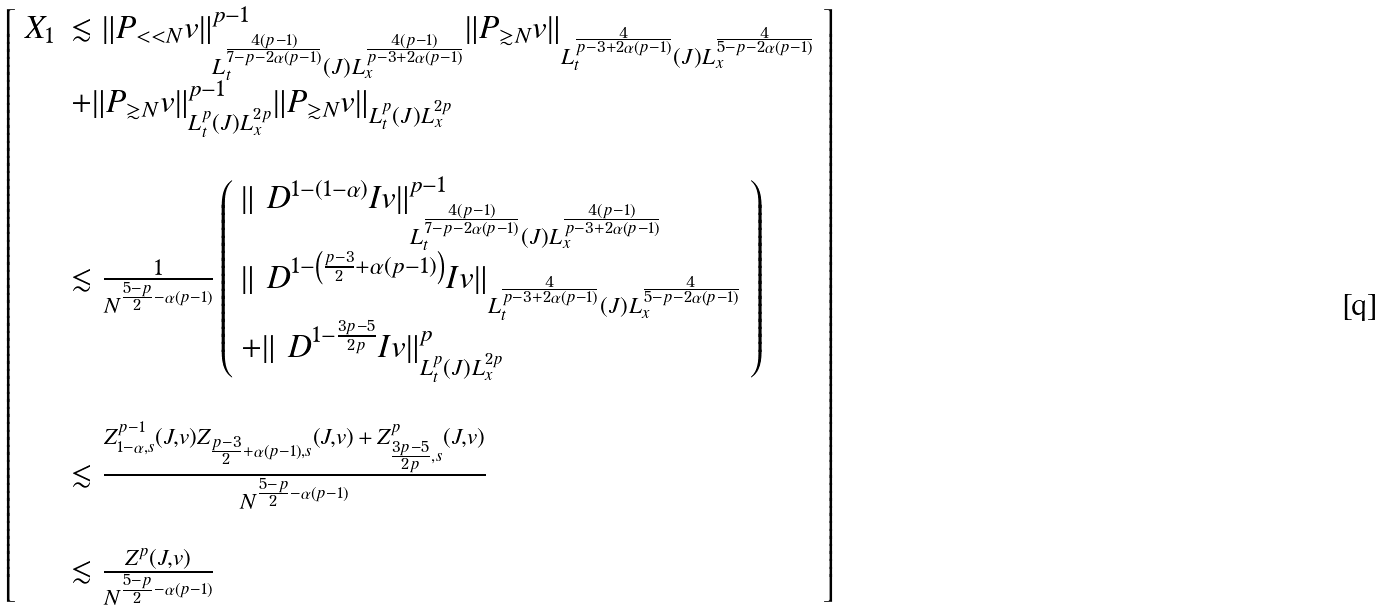Convert formula to latex. <formula><loc_0><loc_0><loc_500><loc_500>\left [ \begin{array} { l l } X _ { 1 } & \lesssim \| P _ { < < N } v \| ^ { p - 1 } _ { L _ { t } ^ { \frac { 4 ( p - 1 ) } { 7 - p - 2 \alpha ( p - 1 ) } } ( J ) L _ { x } ^ { \frac { 4 ( p - 1 ) } { p - 3 + 2 \alpha ( p - 1 ) } } } \| P _ { \gtrsim N } v \| _ { L _ { t } ^ { \frac { 4 } { p - 3 + 2 \alpha ( p - 1 ) } } ( J ) L _ { x } ^ { \frac { 4 } { 5 - p - 2 \alpha ( p - 1 ) } } } \\ & + \| P _ { \gtrsim N } v \| _ { L _ { t } ^ { p } ( J ) L _ { x } ^ { 2 p } } ^ { p - 1 } \| P _ { \gtrsim N } v \| _ { L _ { t } ^ { p } ( J ) L _ { x } ^ { 2 p } } \\ & \\ & \lesssim \frac { 1 } { N ^ { \frac { 5 - p } { 2 } - \alpha ( p - 1 ) } } \left ( \begin{array} { l } \| \ D ^ { 1 - ( 1 - \alpha ) } I v \| ^ { p - 1 } _ { L _ { t } ^ { \frac { 4 ( p - 1 ) } { 7 - p - 2 \alpha ( p - 1 ) } } ( J ) L _ { x } ^ { \frac { 4 ( p - 1 ) } { p - 3 + 2 \alpha ( p - 1 ) } } } \\ \| \ D ^ { 1 - \left ( \frac { p - 3 } { 2 } + \alpha ( p - 1 ) \right ) } I v \| _ { L _ { t } ^ { \frac { 4 } { p - 3 + 2 \alpha ( p - 1 ) } } ( J ) L _ { x } ^ { \frac { 4 } { 5 - p - 2 \alpha ( p - 1 ) } } } \\ + \| \ D ^ { 1 - \frac { 3 p - 5 } { 2 p } } I v \| ^ { p } _ { L _ { t } ^ { p } ( J ) L _ { x } ^ { 2 p } } \end{array} \right ) \\ & \\ & \lesssim \frac { Z ^ { p - 1 } _ { 1 - \alpha , s } ( J , v ) Z _ { \frac { p - 3 } { 2 } + \alpha ( p - 1 ) , s } ( J , v ) \, + \, Z ^ { p } _ { \frac { 3 p - 5 } { 2 p } , s } ( J , v ) } { N ^ { \frac { 5 - p } { 2 } - \alpha ( p - 1 ) } } \\ & \\ & \lesssim \frac { Z ^ { p } ( J , v ) } { N ^ { \frac { 5 - p } { 2 } - \alpha ( p - 1 ) } } \end{array} \right ]</formula> 